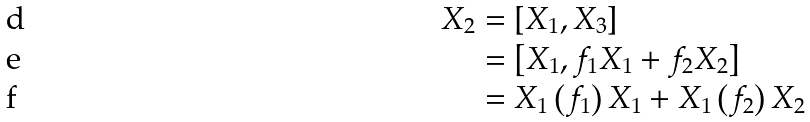<formula> <loc_0><loc_0><loc_500><loc_500>X _ { 2 } & = \left [ X _ { 1 } , X _ { 3 } \right ] \\ & = \left [ X _ { 1 } , f _ { 1 } X _ { 1 } + f _ { 2 } X _ { 2 } \right ] \\ & = X _ { 1 } \left ( f _ { 1 } \right ) X _ { 1 } + X _ { 1 } \left ( f _ { 2 } \right ) X _ { 2 }</formula> 